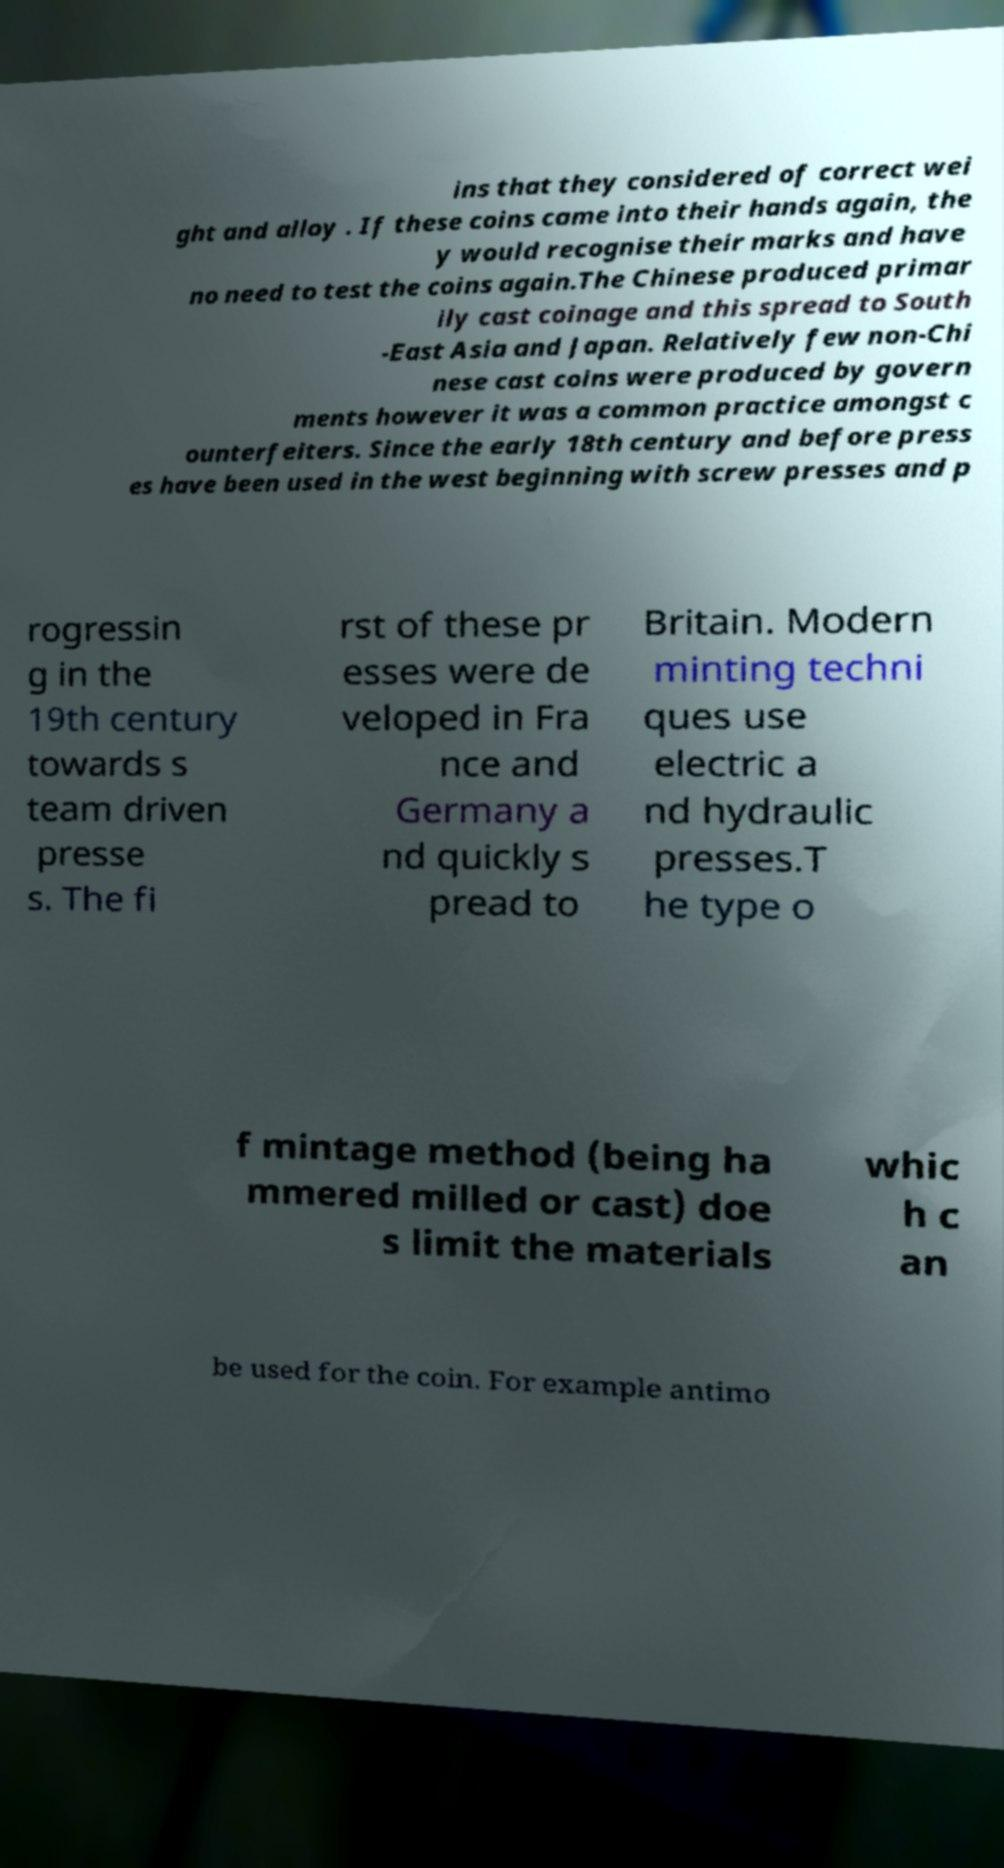Please read and relay the text visible in this image. What does it say? ins that they considered of correct wei ght and alloy . If these coins came into their hands again, the y would recognise their marks and have no need to test the coins again.The Chinese produced primar ily cast coinage and this spread to South -East Asia and Japan. Relatively few non-Chi nese cast coins were produced by govern ments however it was a common practice amongst c ounterfeiters. Since the early 18th century and before press es have been used in the west beginning with screw presses and p rogressin g in the 19th century towards s team driven presse s. The fi rst of these pr esses were de veloped in Fra nce and Germany a nd quickly s pread to Britain. Modern minting techni ques use electric a nd hydraulic presses.T he type o f mintage method (being ha mmered milled or cast) doe s limit the materials whic h c an be used for the coin. For example antimo 